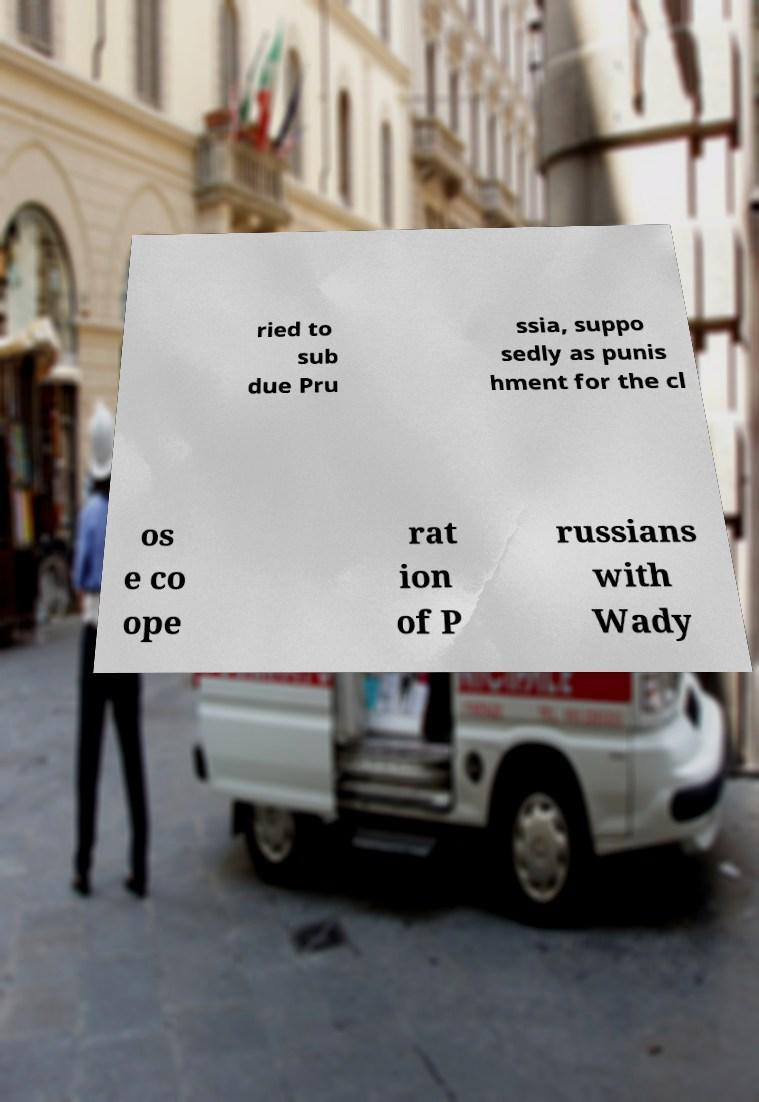Please identify and transcribe the text found in this image. ried to sub due Pru ssia, suppo sedly as punis hment for the cl os e co ope rat ion of P russians with Wady 